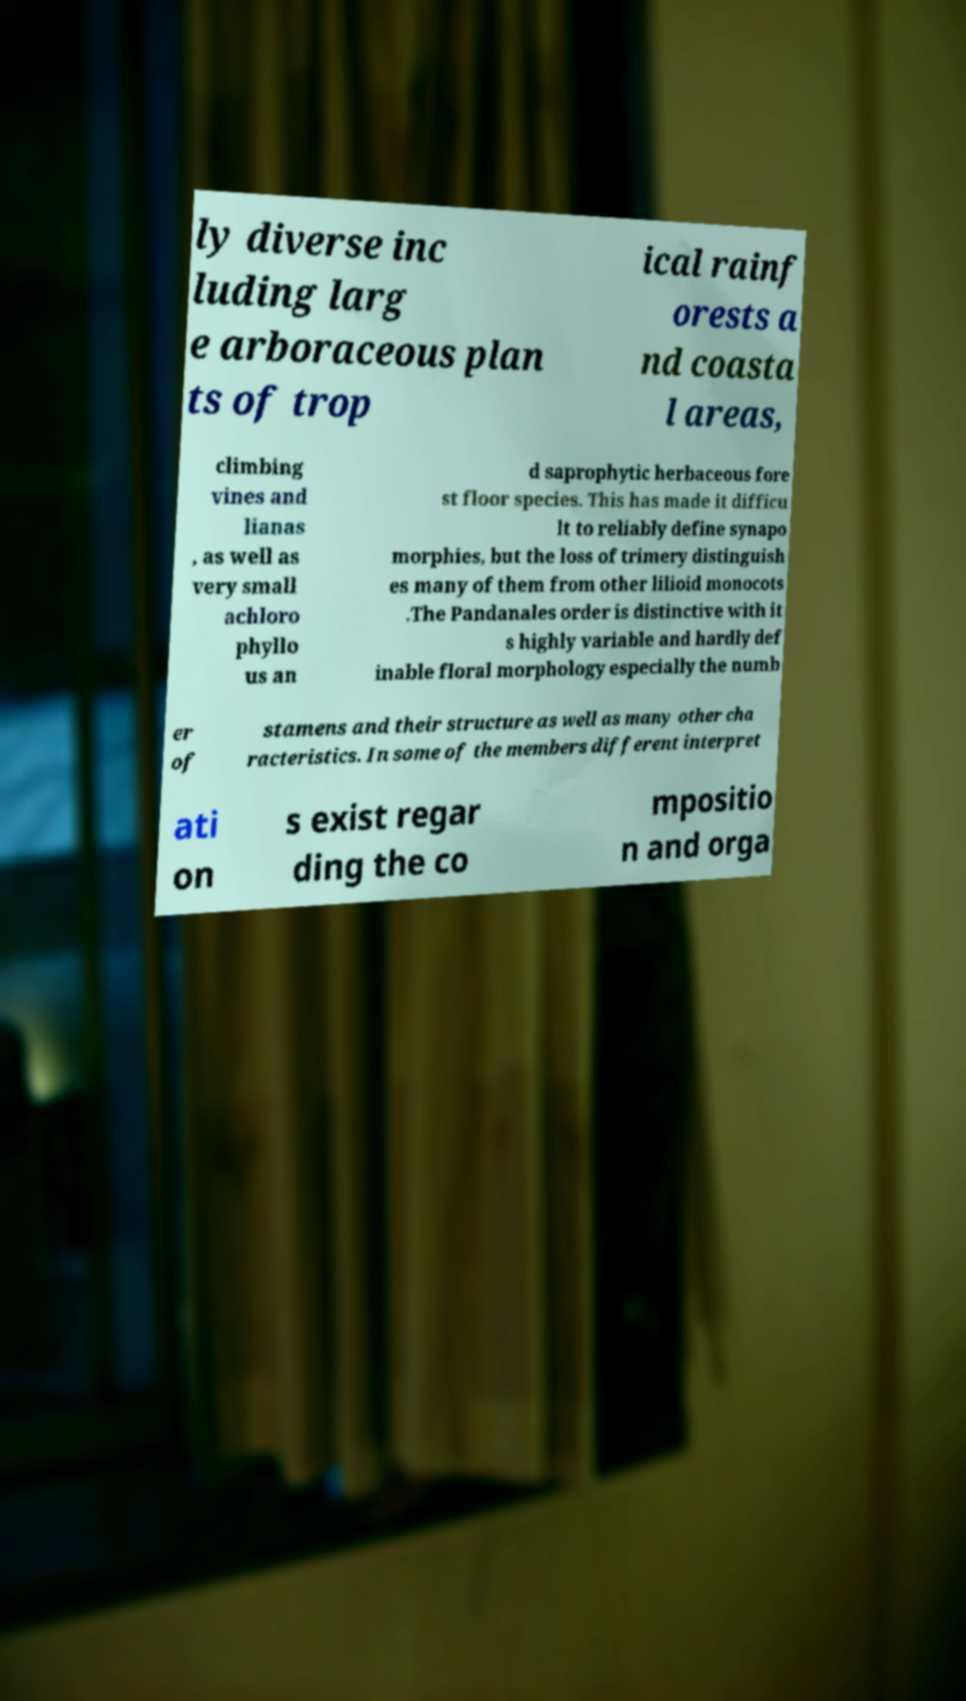Can you read and provide the text displayed in the image?This photo seems to have some interesting text. Can you extract and type it out for me? ly diverse inc luding larg e arboraceous plan ts of trop ical rainf orests a nd coasta l areas, climbing vines and lianas , as well as very small achloro phyllo us an d saprophytic herbaceous fore st floor species. This has made it difficu lt to reliably define synapo morphies, but the loss of trimery distinguish es many of them from other lilioid monocots .The Pandanales order is distinctive with it s highly variable and hardly def inable floral morphology especially the numb er of stamens and their structure as well as many other cha racteristics. In some of the members different interpret ati on s exist regar ding the co mpositio n and orga 